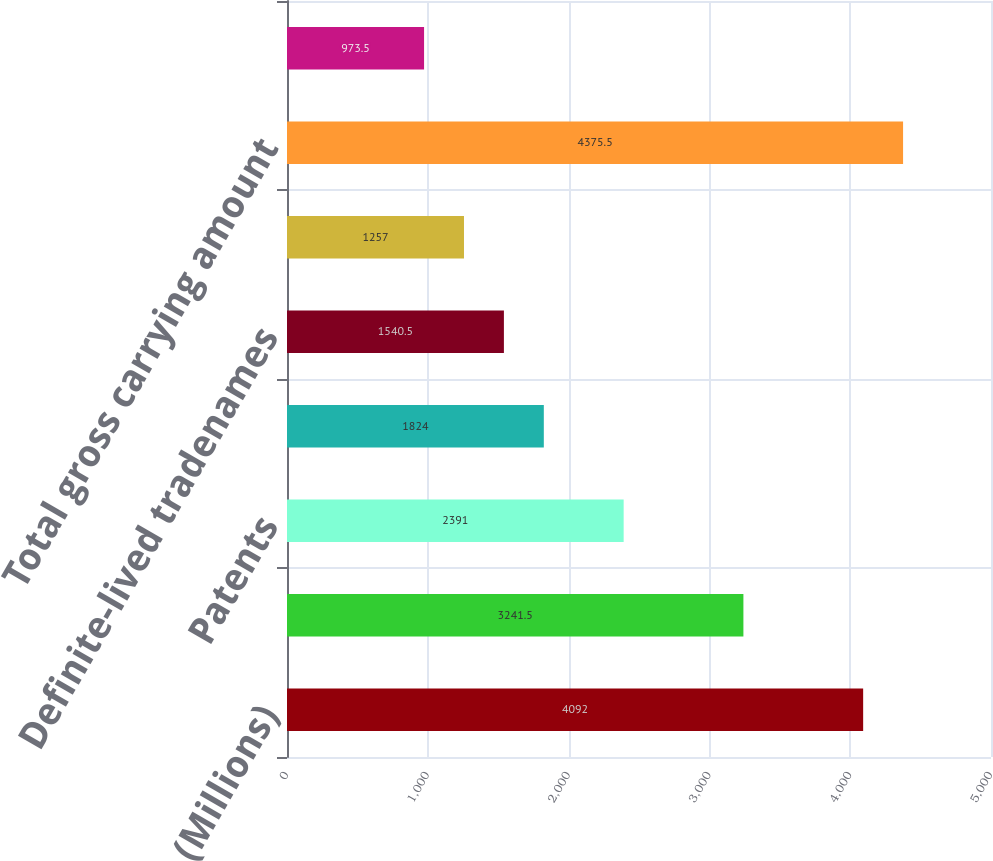Convert chart to OTSL. <chart><loc_0><loc_0><loc_500><loc_500><bar_chart><fcel>(Millions)<fcel>Customer related intangible<fcel>Patents<fcel>Other technology-based<fcel>Definite-lived tradenames<fcel>Other amortizable intangible<fcel>Total gross carrying amount<fcel>Accumulated amortization -<nl><fcel>4092<fcel>3241.5<fcel>2391<fcel>1824<fcel>1540.5<fcel>1257<fcel>4375.5<fcel>973.5<nl></chart> 